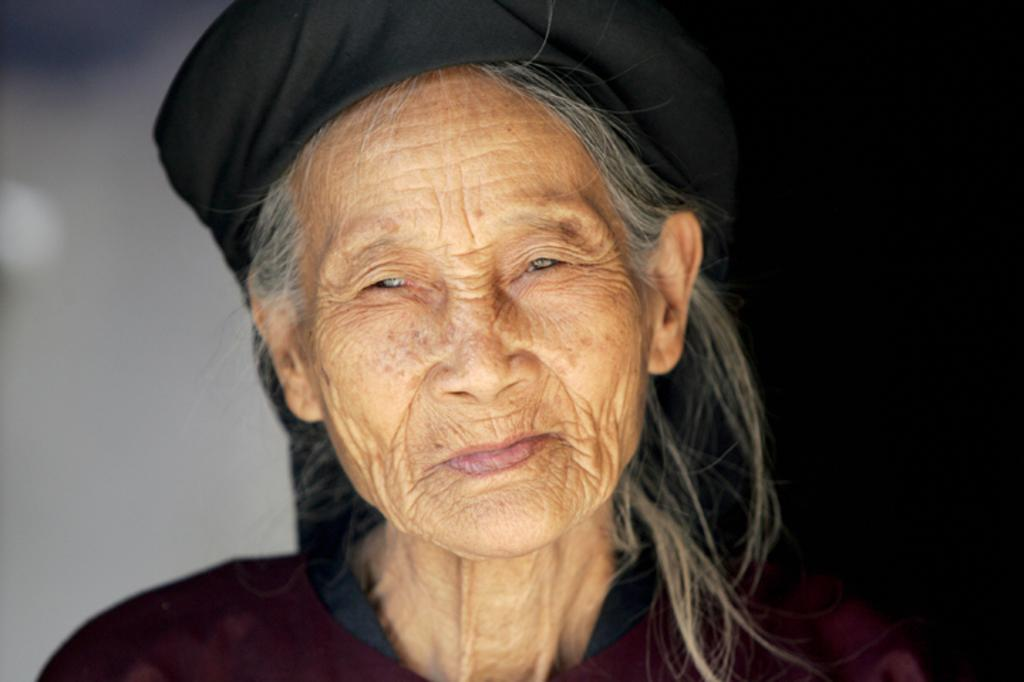Who is the main subject in the image? There is a woman in the image. Can you describe the background of the image? The background of the image is blurred. How many apples are being held by the woman in the image? There is no mention of apples or any other objects being held by the woman in the image. 